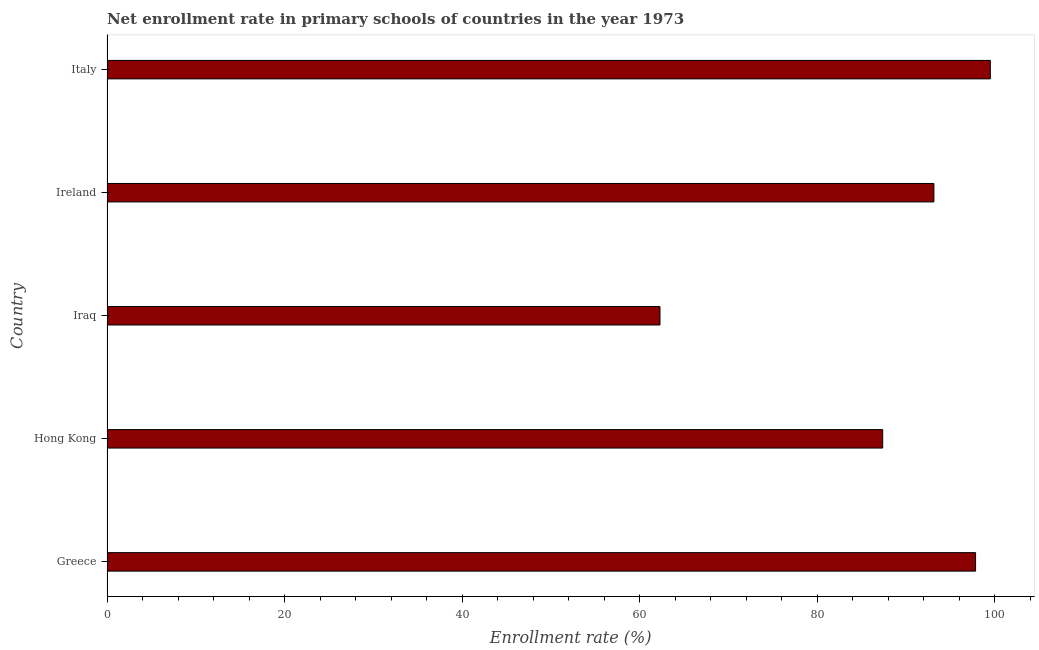Does the graph contain any zero values?
Your response must be concise. No. Does the graph contain grids?
Your answer should be very brief. No. What is the title of the graph?
Keep it short and to the point. Net enrollment rate in primary schools of countries in the year 1973. What is the label or title of the X-axis?
Offer a terse response. Enrollment rate (%). What is the label or title of the Y-axis?
Give a very brief answer. Country. What is the net enrollment rate in primary schools in Hong Kong?
Keep it short and to the point. 87.37. Across all countries, what is the maximum net enrollment rate in primary schools?
Your response must be concise. 99.49. Across all countries, what is the minimum net enrollment rate in primary schools?
Your answer should be very brief. 62.28. In which country was the net enrollment rate in primary schools minimum?
Your answer should be very brief. Iraq. What is the sum of the net enrollment rate in primary schools?
Offer a very short reply. 440.1. What is the difference between the net enrollment rate in primary schools in Hong Kong and Ireland?
Ensure brevity in your answer.  -5.77. What is the average net enrollment rate in primary schools per country?
Give a very brief answer. 88.02. What is the median net enrollment rate in primary schools?
Your answer should be compact. 93.13. In how many countries, is the net enrollment rate in primary schools greater than 12 %?
Provide a short and direct response. 5. What is the ratio of the net enrollment rate in primary schools in Hong Kong to that in Ireland?
Offer a terse response. 0.94. Is the difference between the net enrollment rate in primary schools in Iraq and Italy greater than the difference between any two countries?
Offer a terse response. Yes. What is the difference between the highest and the second highest net enrollment rate in primary schools?
Offer a terse response. 1.66. What is the difference between the highest and the lowest net enrollment rate in primary schools?
Provide a succinct answer. 37.21. How many bars are there?
Provide a succinct answer. 5. How many countries are there in the graph?
Ensure brevity in your answer.  5. What is the difference between two consecutive major ticks on the X-axis?
Ensure brevity in your answer.  20. Are the values on the major ticks of X-axis written in scientific E-notation?
Provide a short and direct response. No. What is the Enrollment rate (%) in Greece?
Provide a succinct answer. 97.83. What is the Enrollment rate (%) in Hong Kong?
Make the answer very short. 87.37. What is the Enrollment rate (%) of Iraq?
Provide a succinct answer. 62.28. What is the Enrollment rate (%) in Ireland?
Ensure brevity in your answer.  93.13. What is the Enrollment rate (%) of Italy?
Provide a short and direct response. 99.49. What is the difference between the Enrollment rate (%) in Greece and Hong Kong?
Your answer should be very brief. 10.46. What is the difference between the Enrollment rate (%) in Greece and Iraq?
Make the answer very short. 35.55. What is the difference between the Enrollment rate (%) in Greece and Ireland?
Give a very brief answer. 4.69. What is the difference between the Enrollment rate (%) in Greece and Italy?
Ensure brevity in your answer.  -1.66. What is the difference between the Enrollment rate (%) in Hong Kong and Iraq?
Offer a very short reply. 25.09. What is the difference between the Enrollment rate (%) in Hong Kong and Ireland?
Give a very brief answer. -5.77. What is the difference between the Enrollment rate (%) in Hong Kong and Italy?
Provide a succinct answer. -12.12. What is the difference between the Enrollment rate (%) in Iraq and Ireland?
Offer a terse response. -30.85. What is the difference between the Enrollment rate (%) in Iraq and Italy?
Make the answer very short. -37.21. What is the difference between the Enrollment rate (%) in Ireland and Italy?
Offer a very short reply. -6.35. What is the ratio of the Enrollment rate (%) in Greece to that in Hong Kong?
Ensure brevity in your answer.  1.12. What is the ratio of the Enrollment rate (%) in Greece to that in Iraq?
Provide a short and direct response. 1.57. What is the ratio of the Enrollment rate (%) in Hong Kong to that in Iraq?
Offer a very short reply. 1.4. What is the ratio of the Enrollment rate (%) in Hong Kong to that in Ireland?
Offer a terse response. 0.94. What is the ratio of the Enrollment rate (%) in Hong Kong to that in Italy?
Make the answer very short. 0.88. What is the ratio of the Enrollment rate (%) in Iraq to that in Ireland?
Provide a succinct answer. 0.67. What is the ratio of the Enrollment rate (%) in Iraq to that in Italy?
Offer a terse response. 0.63. What is the ratio of the Enrollment rate (%) in Ireland to that in Italy?
Give a very brief answer. 0.94. 